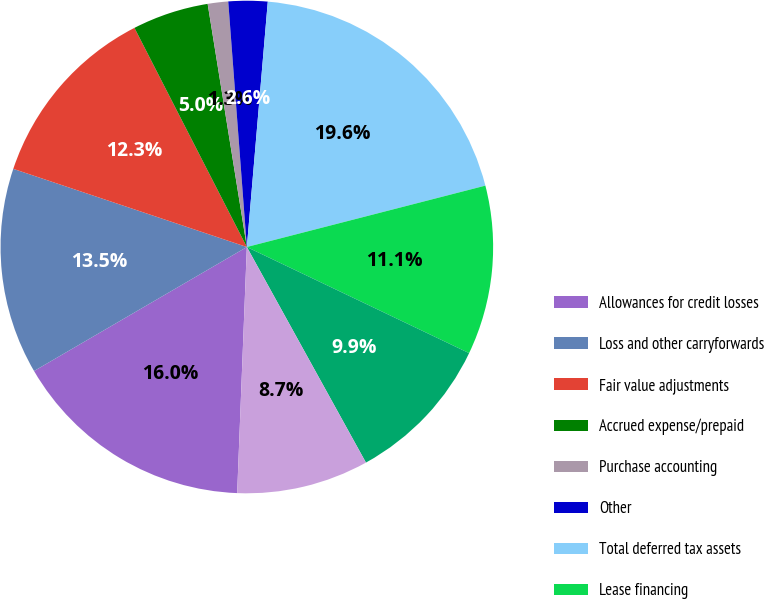Convert chart. <chart><loc_0><loc_0><loc_500><loc_500><pie_chart><fcel>Allowances for credit losses<fcel>Loss and other carryforwards<fcel>Fair value adjustments<fcel>Accrued expense/prepaid<fcel>Purchase accounting<fcel>Other<fcel>Total deferred tax assets<fcel>Lease financing<fcel>Loan origination costs<fcel>Mortgage servicing rights<nl><fcel>15.98%<fcel>13.54%<fcel>12.32%<fcel>5.0%<fcel>1.34%<fcel>2.56%<fcel>19.64%<fcel>11.1%<fcel>9.88%<fcel>8.66%<nl></chart> 